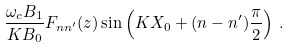Convert formula to latex. <formula><loc_0><loc_0><loc_500><loc_500>\frac { \omega _ { c } B _ { 1 } } { K B _ { 0 } } F _ { n n ^ { \prime } } ( z ) \sin \left ( K X _ { 0 } + ( n - n ^ { \prime } ) \frac { \pi } { 2 } \right ) \, .</formula> 